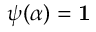<formula> <loc_0><loc_0><loc_500><loc_500>\psi ( ) =</formula> 